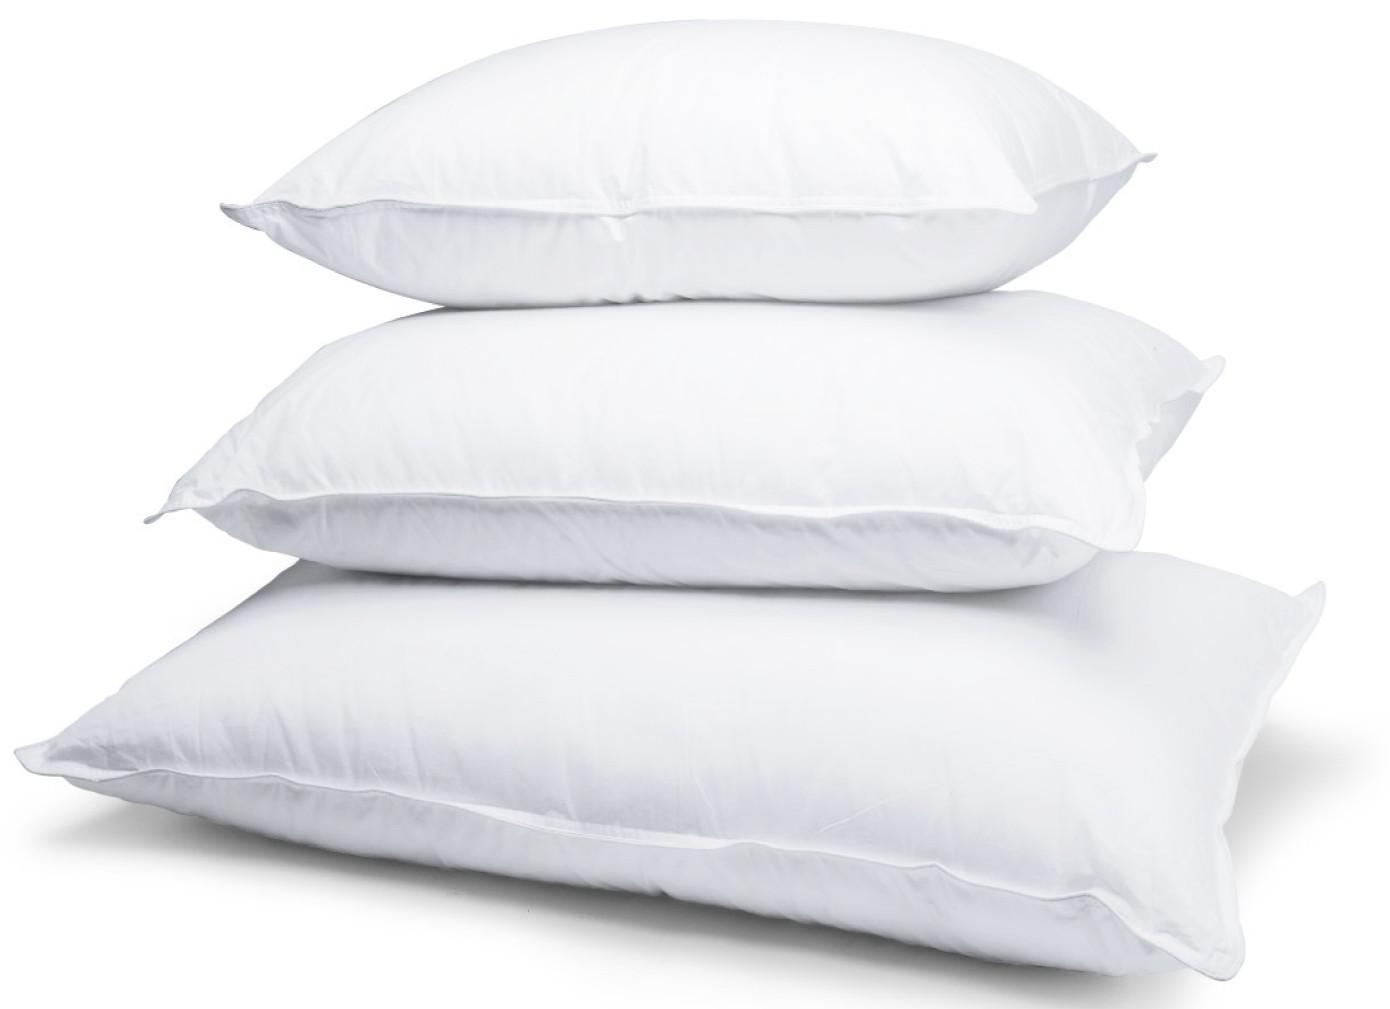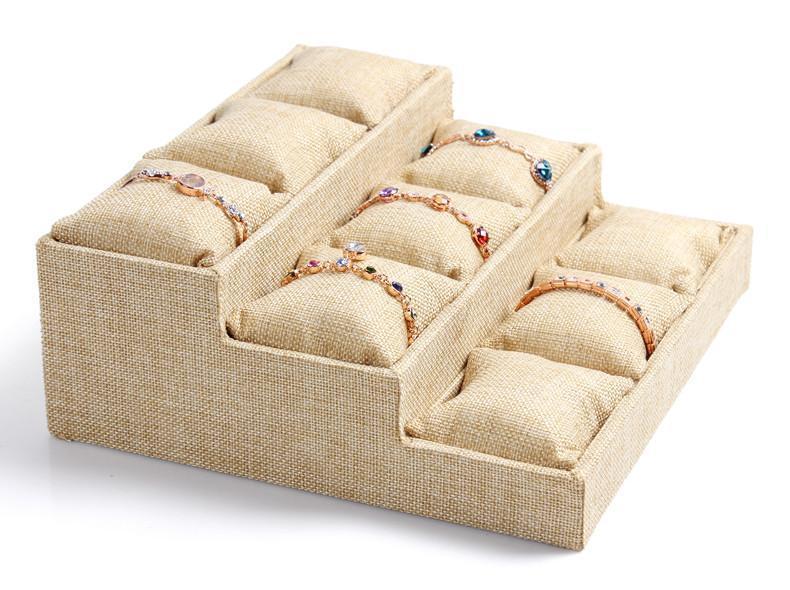The first image is the image on the left, the second image is the image on the right. For the images displayed, is the sentence "The right image contains three pillows stacked on top of each other." factually correct? Answer yes or no. No. The first image is the image on the left, the second image is the image on the right. Evaluate the accuracy of this statement regarding the images: "The lefthand image contains a vertical stack of three solid-white pillows.". Is it true? Answer yes or no. Yes. 